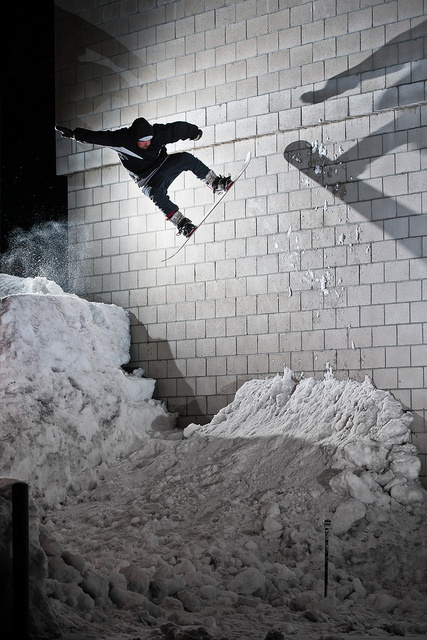Describe the objects in this image and their specific colors. I can see people in black, gray, darkgray, and lightgray tones and snowboard in black, lightgray, darkgray, gray, and maroon tones in this image. 